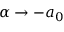<formula> <loc_0><loc_0><loc_500><loc_500>\alpha \to - a _ { 0 }</formula> 